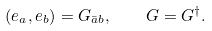<formula> <loc_0><loc_0><loc_500><loc_500>( e _ { a } , e _ { b } ) = G _ { { \bar { a } } b } , \quad G = G ^ { \dagger } .</formula> 